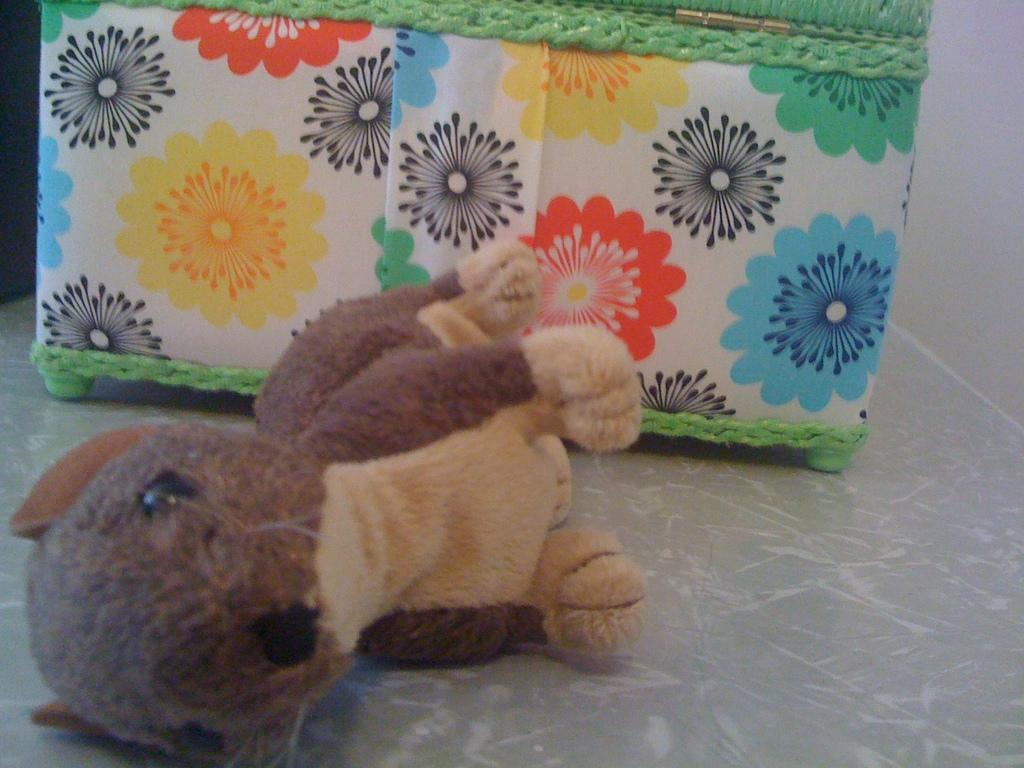What is placed on the floor in the image? There is a doll placed on the floor in the image. What object can be seen near the wall in the image? There is a box near the wall in the image. What story does the doll tell in the image? The image does not depict the doll telling a story, nor does it provide any information about a story. 